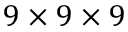<formula> <loc_0><loc_0><loc_500><loc_500>9 \times 9 \times 9</formula> 